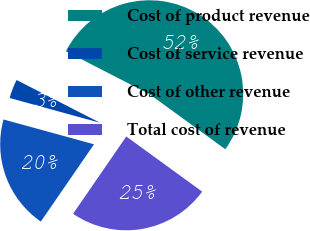Convert chart. <chart><loc_0><loc_0><loc_500><loc_500><pie_chart><fcel>Cost of product revenue<fcel>Cost of service revenue<fcel>Cost of other revenue<fcel>Total cost of revenue<nl><fcel>52.46%<fcel>3.28%<fcel>19.67%<fcel>24.59%<nl></chart> 